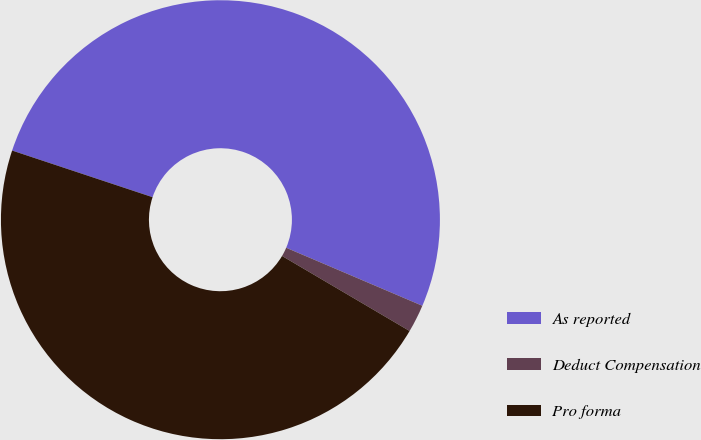Convert chart to OTSL. <chart><loc_0><loc_0><loc_500><loc_500><pie_chart><fcel>As reported<fcel>Deduct Compensation<fcel>Pro forma<nl><fcel>51.31%<fcel>2.05%<fcel>46.64%<nl></chart> 